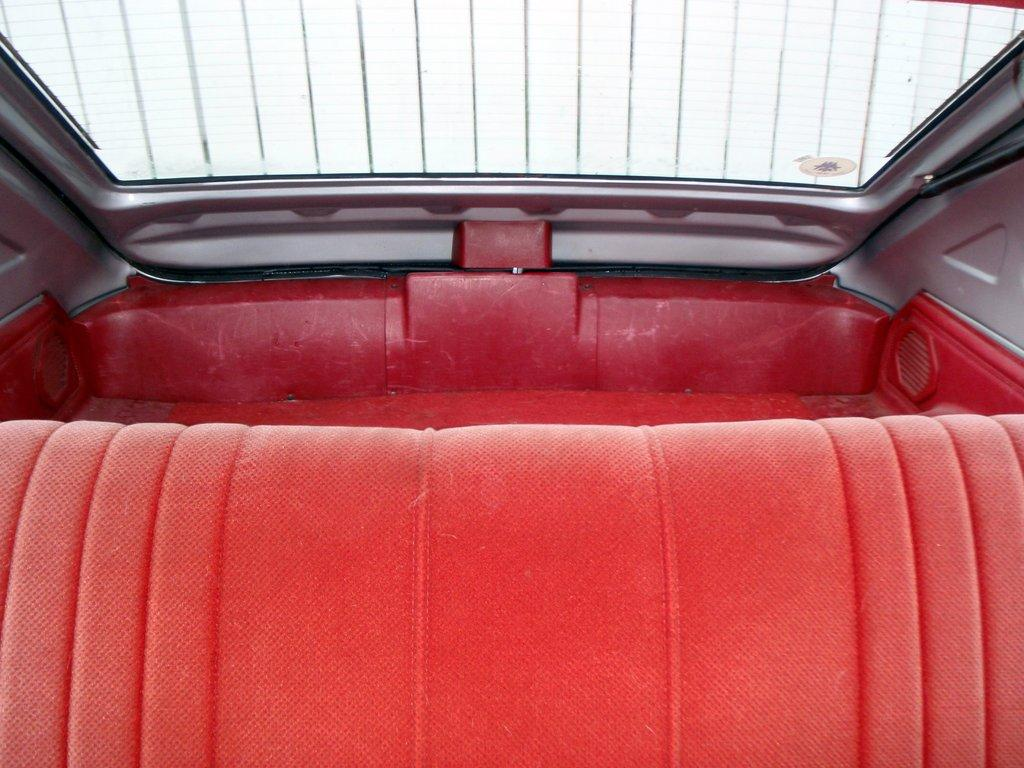What type of setting is depicted in the image? The image shows an inside view of a car. What can be seen inside the car? There is a seat visible in the car. What type of juice can be seen being poured by the duck in the image? There is no juice or duck present in the image; it only shows an inside view of a car with a seat. 